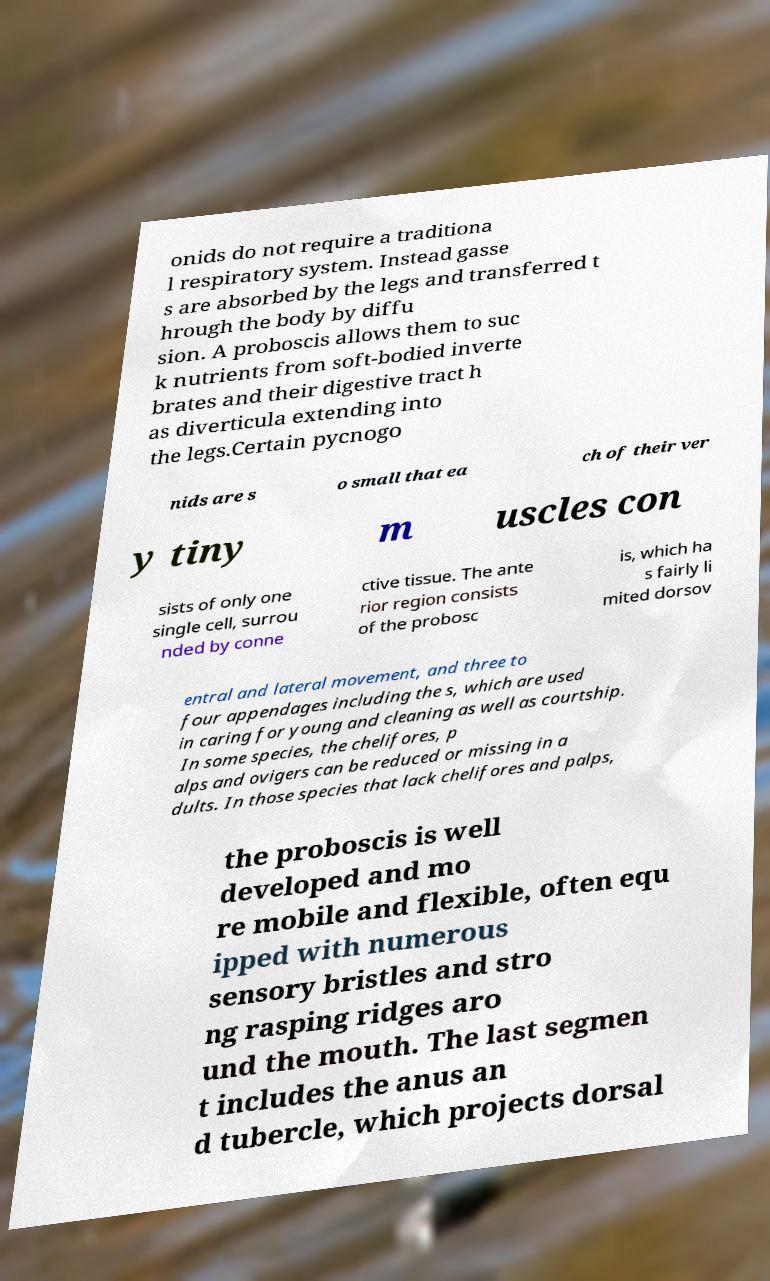For documentation purposes, I need the text within this image transcribed. Could you provide that? onids do not require a traditiona l respiratory system. Instead gasse s are absorbed by the legs and transferred t hrough the body by diffu sion. A proboscis allows them to suc k nutrients from soft-bodied inverte brates and their digestive tract h as diverticula extending into the legs.Certain pycnogo nids are s o small that ea ch of their ver y tiny m uscles con sists of only one single cell, surrou nded by conne ctive tissue. The ante rior region consists of the probosc is, which ha s fairly li mited dorsov entral and lateral movement, and three to four appendages including the s, which are used in caring for young and cleaning as well as courtship. In some species, the chelifores, p alps and ovigers can be reduced or missing in a dults. In those species that lack chelifores and palps, the proboscis is well developed and mo re mobile and flexible, often equ ipped with numerous sensory bristles and stro ng rasping ridges aro und the mouth. The last segmen t includes the anus an d tubercle, which projects dorsal 